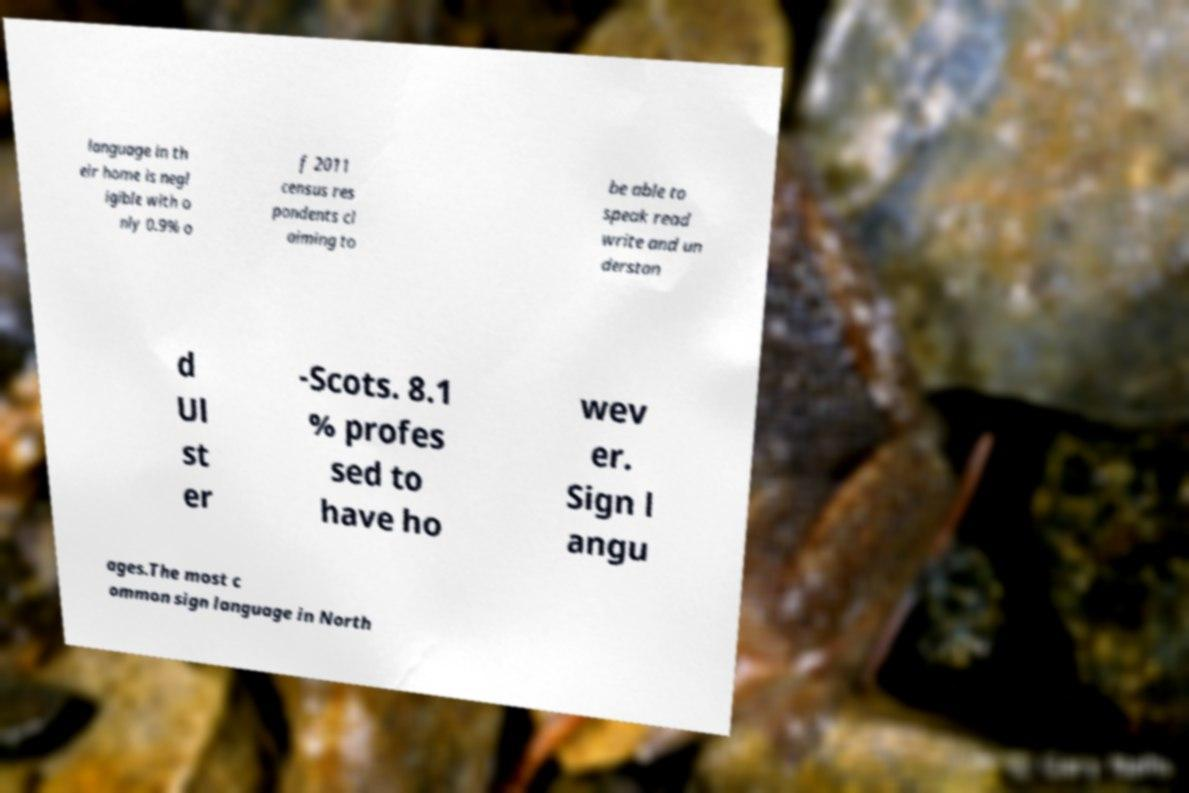Could you extract and type out the text from this image? language in th eir home is negl igible with o nly 0.9% o f 2011 census res pondents cl aiming to be able to speak read write and un derstan d Ul st er -Scots. 8.1 % profes sed to have ho wev er. Sign l angu ages.The most c ommon sign language in North 